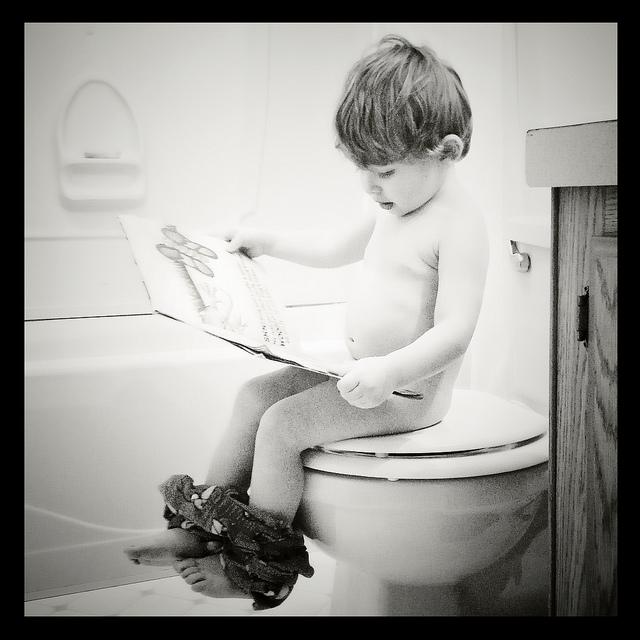Where is the child sitting?
Quick response, please. Toilet. How old is the boy in the photo?
Short answer required. 2. What is he reading?
Concise answer only. Book. Can he do "potty" with the lid down?
Give a very brief answer. No. Is there someone sitting?
Write a very short answer. Yes. 